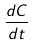<formula> <loc_0><loc_0><loc_500><loc_500>\frac { d C } { d t }</formula> 